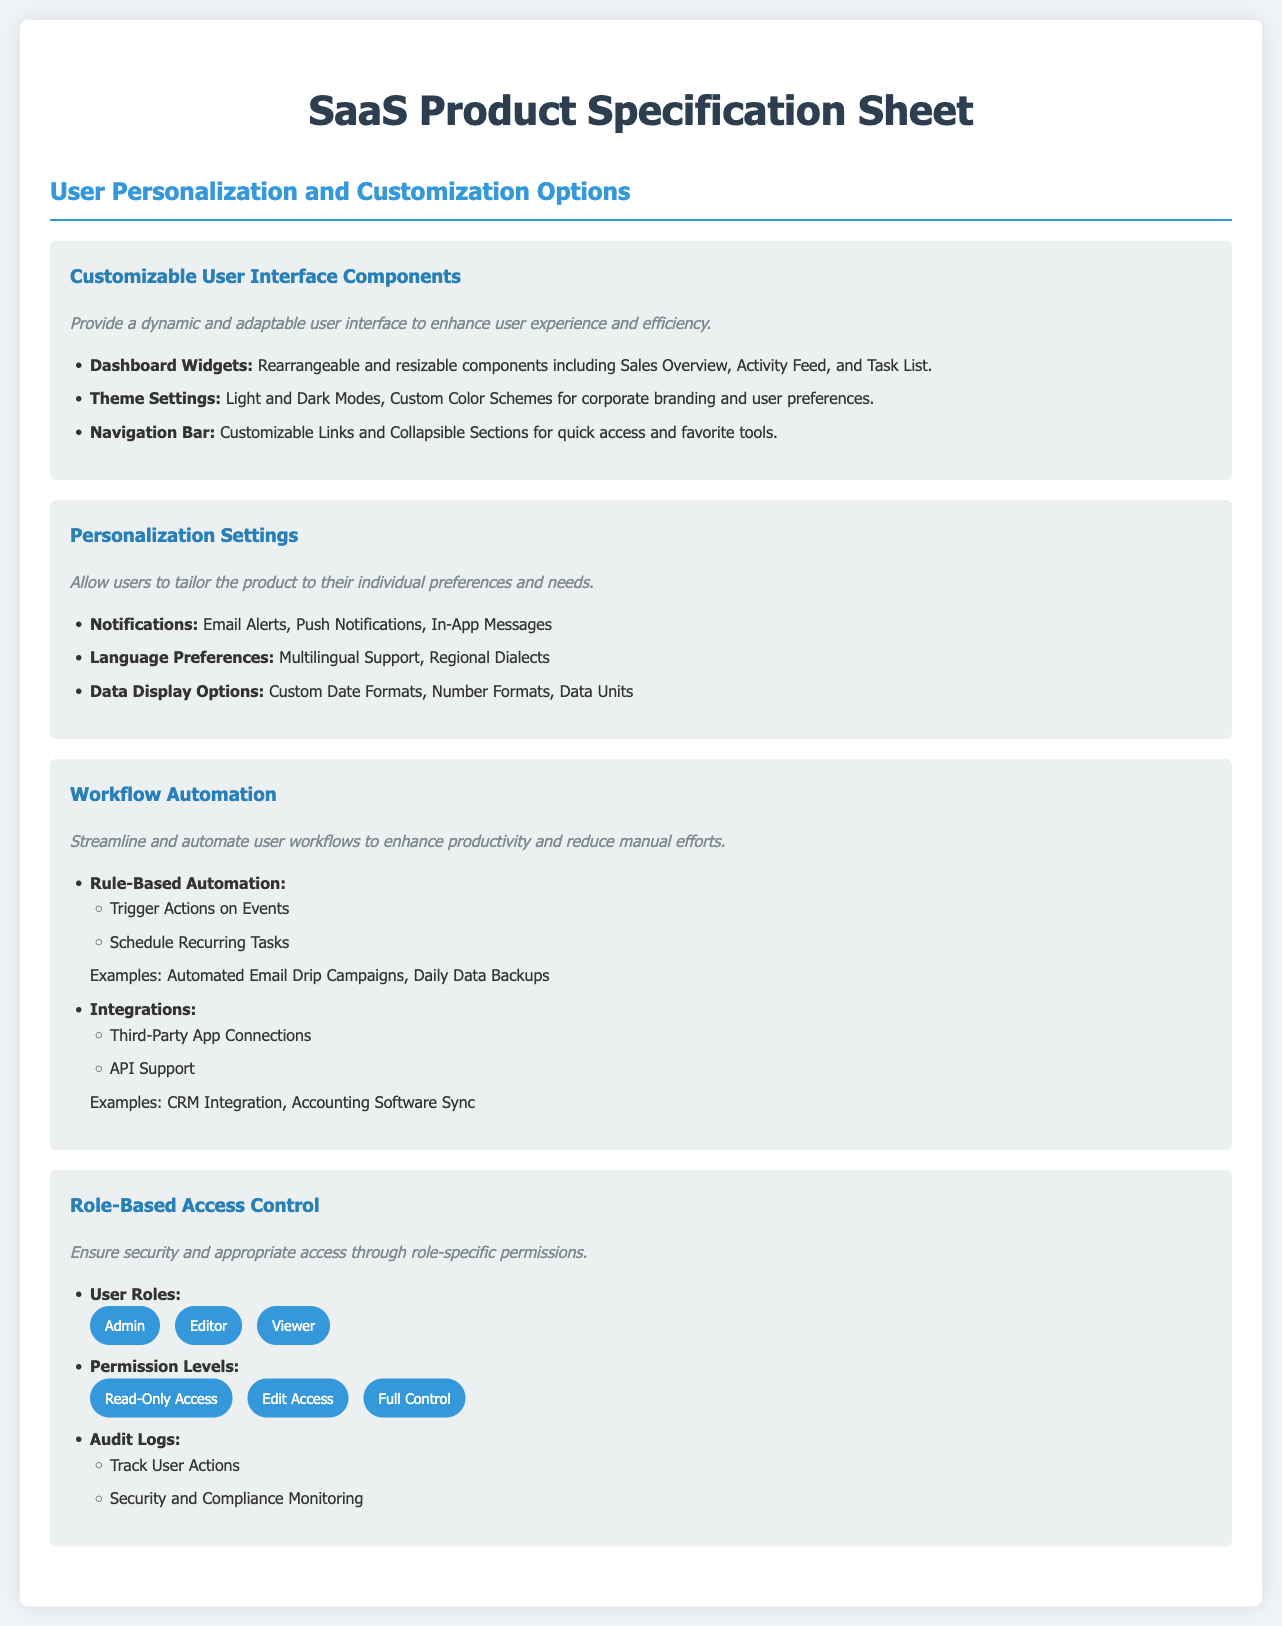What are the customizable user interface components? The section lists specific components that can be customized, including Dashboard Widgets, Theme Settings, and Navigation Bar.
Answer: Dashboard Widgets, Theme Settings, Navigation Bar What options are available for notifications? This refers to a specific item in the Personalization Settings which provides different methods of notifications mentioned in the document.
Answer: Email Alerts, Push Notifications, In-App Messages How many user roles are defined in the Role-Based Access Control? The document specifies three distinct user roles under the Role-Based Access Control section.
Answer: Three What is one example of rule-based automation mentioned? This is found under the Workflow Automation section that provides real-world examples of rules that can be automated.
Answer: Automated Email Drip Campaigns What two modes for theme settings are provided? The document highlights the availability of different modes within the Theme Settings.
Answer: Light and Dark Modes What are the permission levels listed in Role-Based Access Control? The document details specific permission levels users can have within the Role-Based Access Control section.
Answer: Read-Only Access, Edit Access, Full Control What type of support is mentioned under Integrations? Refers to specific types of technological support for integrating other applications, as detailed in the Workflow Automation section.
Answer: API Support How does the document describe Workflow Automation? This question helps to evaluate how the document outlines the aim or purpose of workflow automation as stated in the respective section.
Answer: Streamline and automate user workflows What security feature is included in the Role-Based Access Control? This asks for a specific security feature found in the Role-Based Access Control section regarding oversight and monitoring.
Answer: Audit Logs 